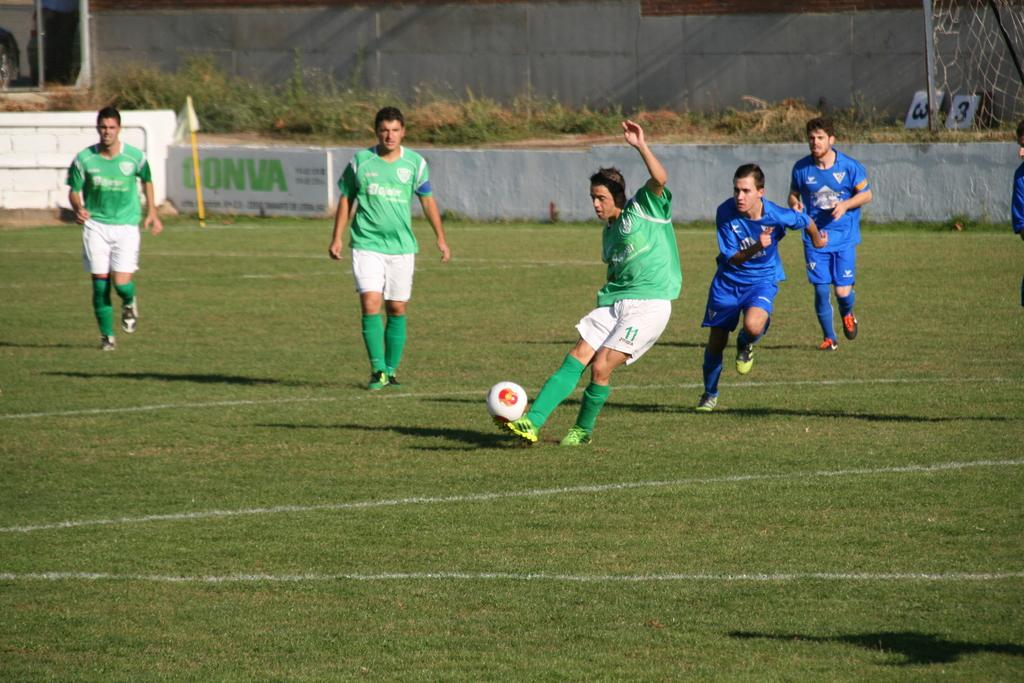<image>
Render a clear and concise summary of the photo. Player number 11 has one arm up as he prepares to kick the ball. 